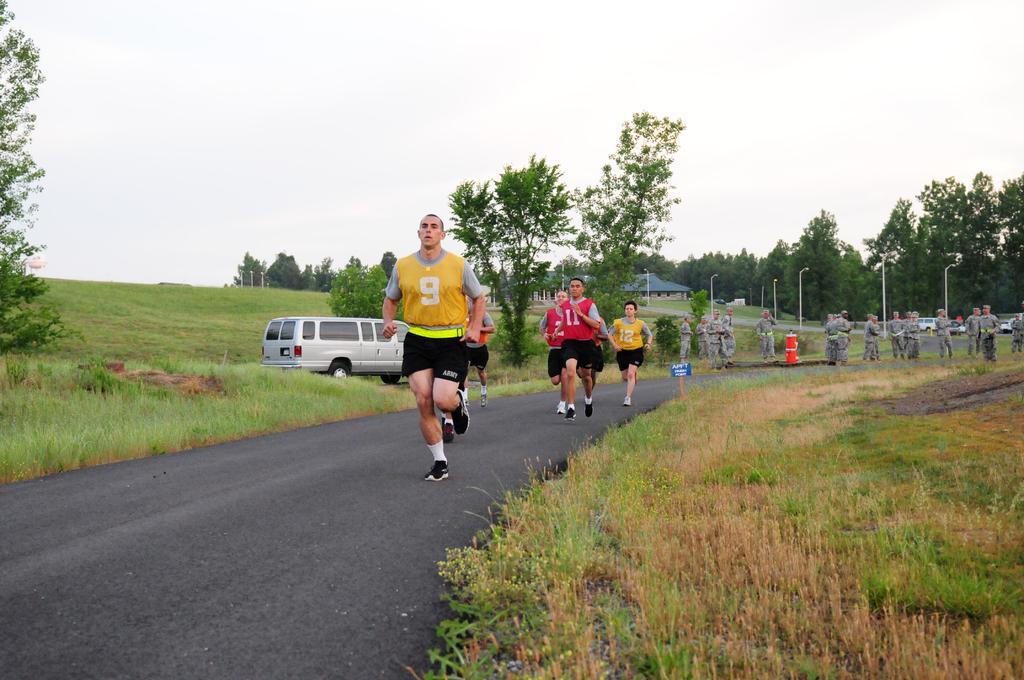How would you summarize this image in a sentence or two? In this image I can see people were most of them are wearing uniforms. Here I can see something is written on their dresses. I can also see road, a vehicle, grass, a blue colour board and over there I can see a red colour thing. I can also see something is written on this board. In the background I can see number of trees, number of poles, street lights and over there I can see a building. I can also see few more vehicles in background. 